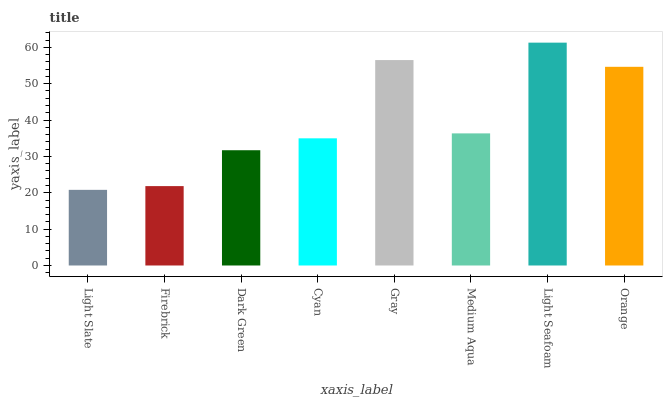Is Light Slate the minimum?
Answer yes or no. Yes. Is Light Seafoam the maximum?
Answer yes or no. Yes. Is Firebrick the minimum?
Answer yes or no. No. Is Firebrick the maximum?
Answer yes or no. No. Is Firebrick greater than Light Slate?
Answer yes or no. Yes. Is Light Slate less than Firebrick?
Answer yes or no. Yes. Is Light Slate greater than Firebrick?
Answer yes or no. No. Is Firebrick less than Light Slate?
Answer yes or no. No. Is Medium Aqua the high median?
Answer yes or no. Yes. Is Cyan the low median?
Answer yes or no. Yes. Is Dark Green the high median?
Answer yes or no. No. Is Medium Aqua the low median?
Answer yes or no. No. 